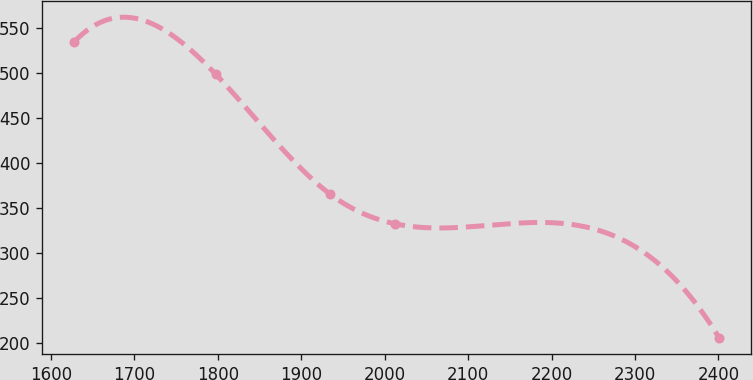<chart> <loc_0><loc_0><loc_500><loc_500><line_chart><ecel><fcel>Unnamed: 1<nl><fcel>1628.09<fcel>534.35<nl><fcel>1797.49<fcel>498.52<nl><fcel>1934.58<fcel>365.24<nl><fcel>2011.86<fcel>332.36<nl><fcel>2400.88<fcel>205.51<nl></chart> 